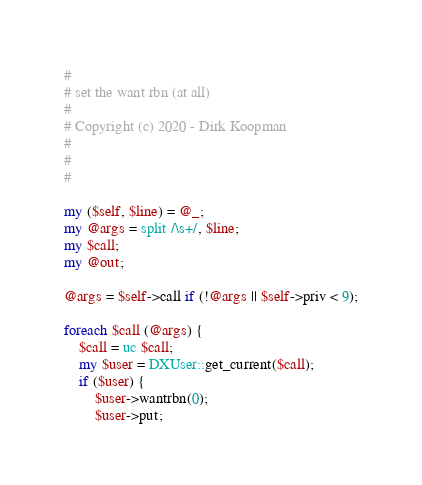<code> <loc_0><loc_0><loc_500><loc_500><_Perl_>#
# set the want rbn (at all)
#
# Copyright (c) 2020 - Dirk Koopman
#
#
#

my ($self, $line) = @_;
my @args = split /\s+/, $line;
my $call;
my @out;

@args = $self->call if (!@args || $self->priv < 9);

foreach $call (@args) {
	$call = uc $call;
	my $user = DXUser::get_current($call);
	if ($user) {
		$user->wantrbn(0);
		$user->put;</code> 